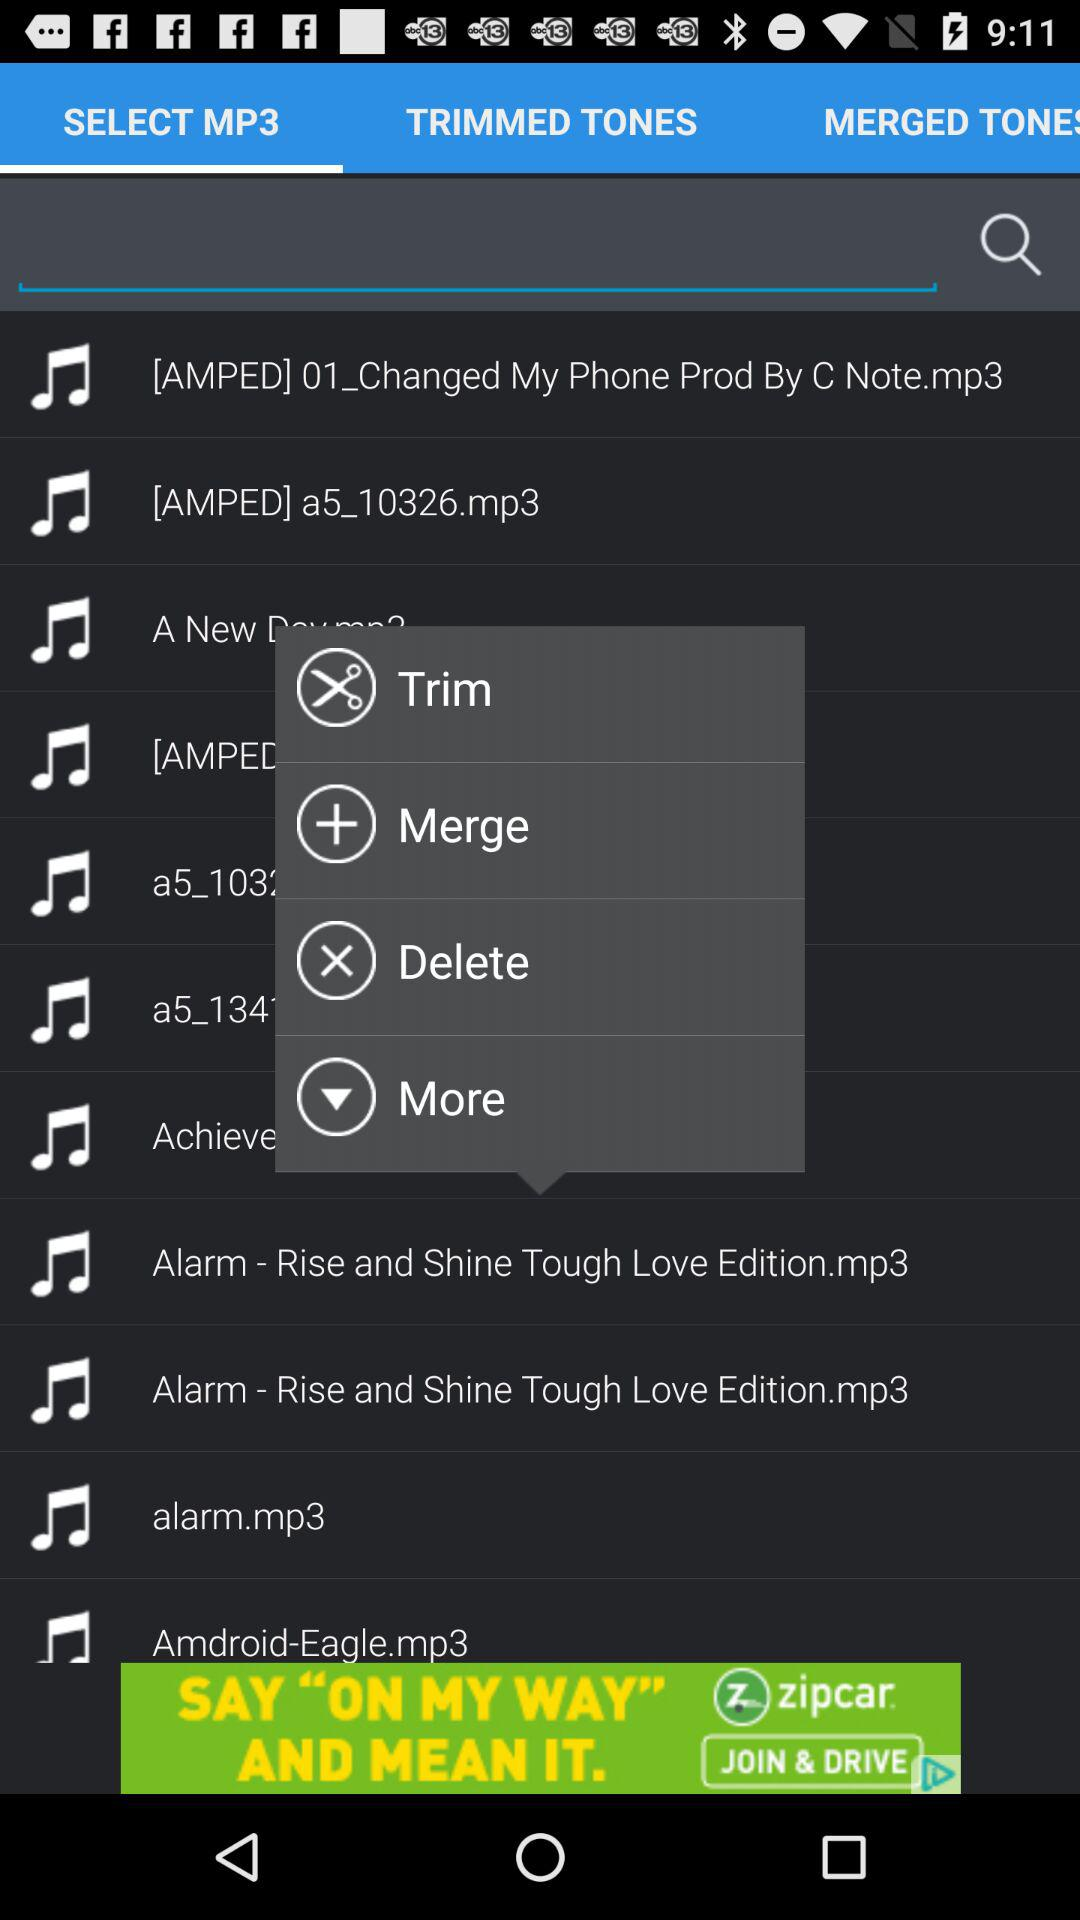Which tab is selected? The selected tab is "SELECT MP3". 